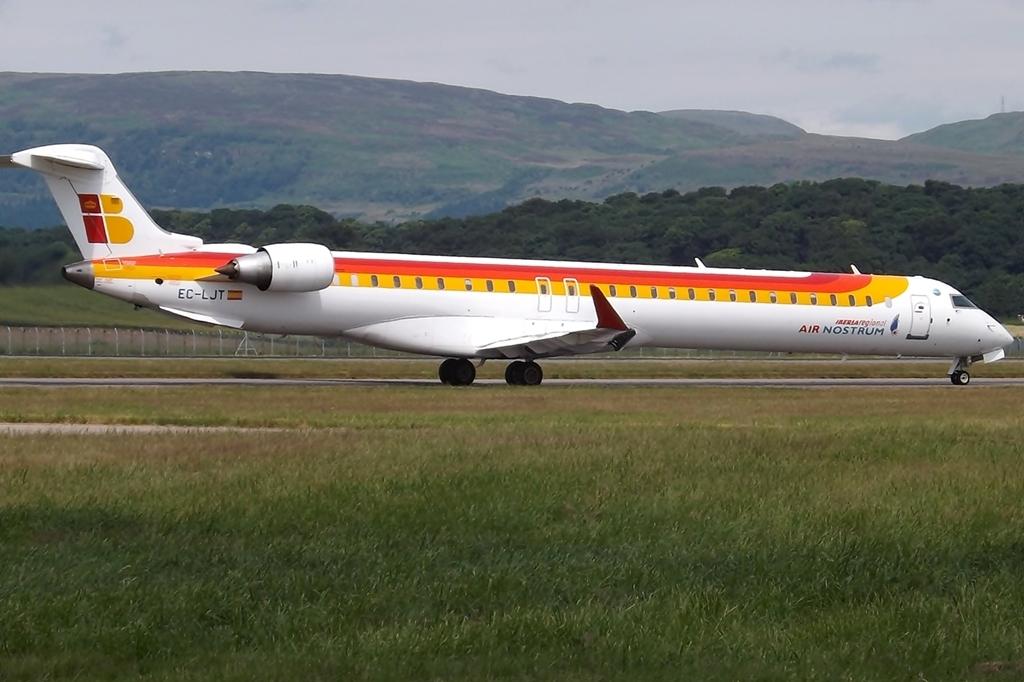What's the plane's flight number?
Your answer should be compact. Ec-ljt. Who is the airline carrier?
Offer a terse response. Air nostrum. 